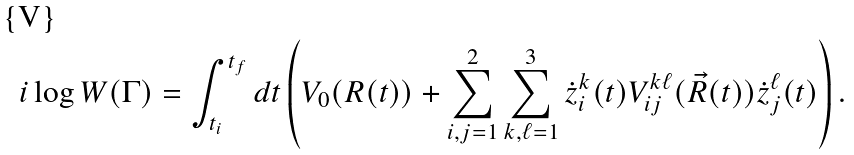Convert formula to latex. <formula><loc_0><loc_0><loc_500><loc_500>i \log W ( \Gamma ) = \int _ { t _ { i } } ^ { t _ { f } } d t \left ( V _ { 0 } ( R ( t ) ) + \sum _ { i , j = 1 } ^ { 2 } \sum _ { k , \ell = 1 } ^ { 3 } \dot { z } _ { i } ^ { k } ( t ) V _ { i j } ^ { k \ell } ( \vec { R } ( t ) ) \dot { z } ^ { \ell } _ { j } ( t ) \right ) .</formula> 